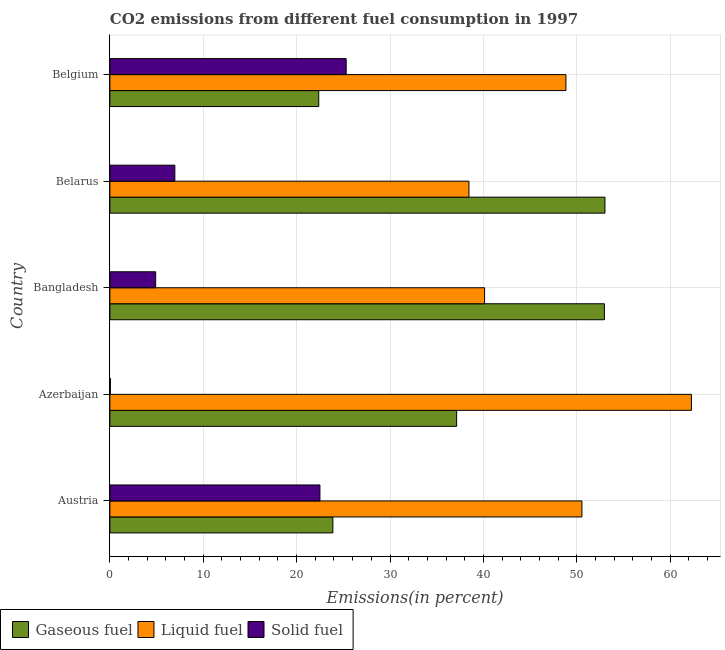How many different coloured bars are there?
Keep it short and to the point. 3. How many groups of bars are there?
Provide a succinct answer. 5. What is the label of the 2nd group of bars from the top?
Your response must be concise. Belarus. What is the percentage of liquid fuel emission in Belgium?
Your answer should be compact. 48.84. Across all countries, what is the maximum percentage of gaseous fuel emission?
Ensure brevity in your answer.  53.02. Across all countries, what is the minimum percentage of gaseous fuel emission?
Provide a succinct answer. 22.37. In which country was the percentage of gaseous fuel emission maximum?
Keep it short and to the point. Belarus. In which country was the percentage of liquid fuel emission minimum?
Offer a very short reply. Belarus. What is the total percentage of liquid fuel emission in the graph?
Provide a succinct answer. 240.27. What is the difference between the percentage of gaseous fuel emission in Austria and that in Azerbaijan?
Offer a terse response. -13.26. What is the difference between the percentage of gaseous fuel emission in Azerbaijan and the percentage of liquid fuel emission in Belgium?
Keep it short and to the point. -11.7. What is the average percentage of solid fuel emission per country?
Give a very brief answer. 11.94. What is the difference between the percentage of gaseous fuel emission and percentage of solid fuel emission in Azerbaijan?
Provide a short and direct response. 37.09. What is the ratio of the percentage of liquid fuel emission in Azerbaijan to that in Belgium?
Keep it short and to the point. 1.27. Is the difference between the percentage of liquid fuel emission in Austria and Bangladesh greater than the difference between the percentage of gaseous fuel emission in Austria and Bangladesh?
Make the answer very short. Yes. What is the difference between the highest and the second highest percentage of gaseous fuel emission?
Offer a terse response. 0.06. What is the difference between the highest and the lowest percentage of gaseous fuel emission?
Offer a terse response. 30.65. In how many countries, is the percentage of solid fuel emission greater than the average percentage of solid fuel emission taken over all countries?
Keep it short and to the point. 2. Is the sum of the percentage of liquid fuel emission in Azerbaijan and Bangladesh greater than the maximum percentage of gaseous fuel emission across all countries?
Give a very brief answer. Yes. What does the 2nd bar from the top in Belarus represents?
Your answer should be compact. Liquid fuel. What does the 3rd bar from the bottom in Azerbaijan represents?
Offer a terse response. Solid fuel. How many countries are there in the graph?
Make the answer very short. 5. What is the difference between two consecutive major ticks on the X-axis?
Ensure brevity in your answer.  10. Does the graph contain grids?
Make the answer very short. Yes. Where does the legend appear in the graph?
Provide a succinct answer. Bottom left. What is the title of the graph?
Ensure brevity in your answer.  CO2 emissions from different fuel consumption in 1997. What is the label or title of the X-axis?
Your answer should be compact. Emissions(in percent). What is the Emissions(in percent) of Gaseous fuel in Austria?
Offer a terse response. 23.88. What is the Emissions(in percent) in Liquid fuel in Austria?
Your response must be concise. 50.56. What is the Emissions(in percent) in Solid fuel in Austria?
Your answer should be very brief. 22.5. What is the Emissions(in percent) of Gaseous fuel in Azerbaijan?
Keep it short and to the point. 37.14. What is the Emissions(in percent) in Liquid fuel in Azerbaijan?
Your answer should be very brief. 62.28. What is the Emissions(in percent) of Solid fuel in Azerbaijan?
Provide a succinct answer. 0.05. What is the Emissions(in percent) in Gaseous fuel in Bangladesh?
Make the answer very short. 52.96. What is the Emissions(in percent) in Liquid fuel in Bangladesh?
Offer a very short reply. 40.13. What is the Emissions(in percent) in Solid fuel in Bangladesh?
Ensure brevity in your answer.  4.9. What is the Emissions(in percent) in Gaseous fuel in Belarus?
Give a very brief answer. 53.02. What is the Emissions(in percent) in Liquid fuel in Belarus?
Offer a terse response. 38.46. What is the Emissions(in percent) of Solid fuel in Belarus?
Your answer should be very brief. 6.96. What is the Emissions(in percent) in Gaseous fuel in Belgium?
Your answer should be compact. 22.37. What is the Emissions(in percent) of Liquid fuel in Belgium?
Ensure brevity in your answer.  48.84. What is the Emissions(in percent) of Solid fuel in Belgium?
Offer a terse response. 25.31. Across all countries, what is the maximum Emissions(in percent) of Gaseous fuel?
Provide a succinct answer. 53.02. Across all countries, what is the maximum Emissions(in percent) of Liquid fuel?
Your answer should be very brief. 62.28. Across all countries, what is the maximum Emissions(in percent) of Solid fuel?
Provide a succinct answer. 25.31. Across all countries, what is the minimum Emissions(in percent) of Gaseous fuel?
Keep it short and to the point. 22.37. Across all countries, what is the minimum Emissions(in percent) in Liquid fuel?
Make the answer very short. 38.46. Across all countries, what is the minimum Emissions(in percent) in Solid fuel?
Provide a succinct answer. 0.05. What is the total Emissions(in percent) of Gaseous fuel in the graph?
Your answer should be compact. 189.38. What is the total Emissions(in percent) of Liquid fuel in the graph?
Provide a succinct answer. 240.27. What is the total Emissions(in percent) of Solid fuel in the graph?
Offer a very short reply. 59.71. What is the difference between the Emissions(in percent) of Gaseous fuel in Austria and that in Azerbaijan?
Your answer should be compact. -13.26. What is the difference between the Emissions(in percent) in Liquid fuel in Austria and that in Azerbaijan?
Provide a short and direct response. -11.73. What is the difference between the Emissions(in percent) of Solid fuel in Austria and that in Azerbaijan?
Your answer should be compact. 22.45. What is the difference between the Emissions(in percent) of Gaseous fuel in Austria and that in Bangladesh?
Offer a very short reply. -29.08. What is the difference between the Emissions(in percent) of Liquid fuel in Austria and that in Bangladesh?
Keep it short and to the point. 10.42. What is the difference between the Emissions(in percent) of Solid fuel in Austria and that in Bangladesh?
Provide a short and direct response. 17.6. What is the difference between the Emissions(in percent) of Gaseous fuel in Austria and that in Belarus?
Offer a very short reply. -29.14. What is the difference between the Emissions(in percent) of Liquid fuel in Austria and that in Belarus?
Your answer should be compact. 12.1. What is the difference between the Emissions(in percent) of Solid fuel in Austria and that in Belarus?
Ensure brevity in your answer.  15.54. What is the difference between the Emissions(in percent) in Gaseous fuel in Austria and that in Belgium?
Ensure brevity in your answer.  1.51. What is the difference between the Emissions(in percent) in Liquid fuel in Austria and that in Belgium?
Offer a terse response. 1.71. What is the difference between the Emissions(in percent) in Solid fuel in Austria and that in Belgium?
Your answer should be very brief. -2.81. What is the difference between the Emissions(in percent) of Gaseous fuel in Azerbaijan and that in Bangladesh?
Provide a short and direct response. -15.82. What is the difference between the Emissions(in percent) of Liquid fuel in Azerbaijan and that in Bangladesh?
Your answer should be very brief. 22.15. What is the difference between the Emissions(in percent) in Solid fuel in Azerbaijan and that in Bangladesh?
Keep it short and to the point. -4.85. What is the difference between the Emissions(in percent) of Gaseous fuel in Azerbaijan and that in Belarus?
Provide a succinct answer. -15.88. What is the difference between the Emissions(in percent) in Liquid fuel in Azerbaijan and that in Belarus?
Make the answer very short. 23.83. What is the difference between the Emissions(in percent) of Solid fuel in Azerbaijan and that in Belarus?
Offer a terse response. -6.91. What is the difference between the Emissions(in percent) in Gaseous fuel in Azerbaijan and that in Belgium?
Keep it short and to the point. 14.77. What is the difference between the Emissions(in percent) of Liquid fuel in Azerbaijan and that in Belgium?
Provide a succinct answer. 13.44. What is the difference between the Emissions(in percent) of Solid fuel in Azerbaijan and that in Belgium?
Your answer should be very brief. -25.26. What is the difference between the Emissions(in percent) of Gaseous fuel in Bangladesh and that in Belarus?
Offer a terse response. -0.06. What is the difference between the Emissions(in percent) of Liquid fuel in Bangladesh and that in Belarus?
Your response must be concise. 1.67. What is the difference between the Emissions(in percent) of Solid fuel in Bangladesh and that in Belarus?
Offer a very short reply. -2.05. What is the difference between the Emissions(in percent) in Gaseous fuel in Bangladesh and that in Belgium?
Ensure brevity in your answer.  30.59. What is the difference between the Emissions(in percent) of Liquid fuel in Bangladesh and that in Belgium?
Provide a short and direct response. -8.71. What is the difference between the Emissions(in percent) in Solid fuel in Bangladesh and that in Belgium?
Keep it short and to the point. -20.41. What is the difference between the Emissions(in percent) of Gaseous fuel in Belarus and that in Belgium?
Provide a succinct answer. 30.65. What is the difference between the Emissions(in percent) of Liquid fuel in Belarus and that in Belgium?
Offer a very short reply. -10.39. What is the difference between the Emissions(in percent) in Solid fuel in Belarus and that in Belgium?
Give a very brief answer. -18.35. What is the difference between the Emissions(in percent) of Gaseous fuel in Austria and the Emissions(in percent) of Liquid fuel in Azerbaijan?
Ensure brevity in your answer.  -38.4. What is the difference between the Emissions(in percent) of Gaseous fuel in Austria and the Emissions(in percent) of Solid fuel in Azerbaijan?
Your response must be concise. 23.83. What is the difference between the Emissions(in percent) in Liquid fuel in Austria and the Emissions(in percent) in Solid fuel in Azerbaijan?
Provide a short and direct response. 50.51. What is the difference between the Emissions(in percent) of Gaseous fuel in Austria and the Emissions(in percent) of Liquid fuel in Bangladesh?
Your answer should be very brief. -16.25. What is the difference between the Emissions(in percent) in Gaseous fuel in Austria and the Emissions(in percent) in Solid fuel in Bangladesh?
Your answer should be compact. 18.98. What is the difference between the Emissions(in percent) in Liquid fuel in Austria and the Emissions(in percent) in Solid fuel in Bangladesh?
Make the answer very short. 45.65. What is the difference between the Emissions(in percent) in Gaseous fuel in Austria and the Emissions(in percent) in Liquid fuel in Belarus?
Provide a succinct answer. -14.57. What is the difference between the Emissions(in percent) of Gaseous fuel in Austria and the Emissions(in percent) of Solid fuel in Belarus?
Your answer should be very brief. 16.93. What is the difference between the Emissions(in percent) of Liquid fuel in Austria and the Emissions(in percent) of Solid fuel in Belarus?
Give a very brief answer. 43.6. What is the difference between the Emissions(in percent) in Gaseous fuel in Austria and the Emissions(in percent) in Liquid fuel in Belgium?
Your answer should be very brief. -24.96. What is the difference between the Emissions(in percent) in Gaseous fuel in Austria and the Emissions(in percent) in Solid fuel in Belgium?
Keep it short and to the point. -1.42. What is the difference between the Emissions(in percent) of Liquid fuel in Austria and the Emissions(in percent) of Solid fuel in Belgium?
Keep it short and to the point. 25.25. What is the difference between the Emissions(in percent) in Gaseous fuel in Azerbaijan and the Emissions(in percent) in Liquid fuel in Bangladesh?
Make the answer very short. -2.99. What is the difference between the Emissions(in percent) in Gaseous fuel in Azerbaijan and the Emissions(in percent) in Solid fuel in Bangladesh?
Offer a terse response. 32.24. What is the difference between the Emissions(in percent) of Liquid fuel in Azerbaijan and the Emissions(in percent) of Solid fuel in Bangladesh?
Offer a very short reply. 57.38. What is the difference between the Emissions(in percent) in Gaseous fuel in Azerbaijan and the Emissions(in percent) in Liquid fuel in Belarus?
Ensure brevity in your answer.  -1.32. What is the difference between the Emissions(in percent) of Gaseous fuel in Azerbaijan and the Emissions(in percent) of Solid fuel in Belarus?
Offer a very short reply. 30.18. What is the difference between the Emissions(in percent) in Liquid fuel in Azerbaijan and the Emissions(in percent) in Solid fuel in Belarus?
Make the answer very short. 55.33. What is the difference between the Emissions(in percent) in Gaseous fuel in Azerbaijan and the Emissions(in percent) in Liquid fuel in Belgium?
Your answer should be compact. -11.7. What is the difference between the Emissions(in percent) in Gaseous fuel in Azerbaijan and the Emissions(in percent) in Solid fuel in Belgium?
Provide a succinct answer. 11.83. What is the difference between the Emissions(in percent) of Liquid fuel in Azerbaijan and the Emissions(in percent) of Solid fuel in Belgium?
Your answer should be very brief. 36.98. What is the difference between the Emissions(in percent) in Gaseous fuel in Bangladesh and the Emissions(in percent) in Liquid fuel in Belarus?
Your response must be concise. 14.51. What is the difference between the Emissions(in percent) of Gaseous fuel in Bangladesh and the Emissions(in percent) of Solid fuel in Belarus?
Keep it short and to the point. 46.01. What is the difference between the Emissions(in percent) in Liquid fuel in Bangladesh and the Emissions(in percent) in Solid fuel in Belarus?
Ensure brevity in your answer.  33.18. What is the difference between the Emissions(in percent) of Gaseous fuel in Bangladesh and the Emissions(in percent) of Liquid fuel in Belgium?
Give a very brief answer. 4.12. What is the difference between the Emissions(in percent) of Gaseous fuel in Bangladesh and the Emissions(in percent) of Solid fuel in Belgium?
Make the answer very short. 27.66. What is the difference between the Emissions(in percent) of Liquid fuel in Bangladesh and the Emissions(in percent) of Solid fuel in Belgium?
Your response must be concise. 14.82. What is the difference between the Emissions(in percent) of Gaseous fuel in Belarus and the Emissions(in percent) of Liquid fuel in Belgium?
Offer a very short reply. 4.18. What is the difference between the Emissions(in percent) in Gaseous fuel in Belarus and the Emissions(in percent) in Solid fuel in Belgium?
Offer a very short reply. 27.72. What is the difference between the Emissions(in percent) in Liquid fuel in Belarus and the Emissions(in percent) in Solid fuel in Belgium?
Your response must be concise. 13.15. What is the average Emissions(in percent) of Gaseous fuel per country?
Make the answer very short. 37.88. What is the average Emissions(in percent) of Liquid fuel per country?
Ensure brevity in your answer.  48.05. What is the average Emissions(in percent) in Solid fuel per country?
Your response must be concise. 11.94. What is the difference between the Emissions(in percent) of Gaseous fuel and Emissions(in percent) of Liquid fuel in Austria?
Keep it short and to the point. -26.67. What is the difference between the Emissions(in percent) of Gaseous fuel and Emissions(in percent) of Solid fuel in Austria?
Offer a very short reply. 1.39. What is the difference between the Emissions(in percent) of Liquid fuel and Emissions(in percent) of Solid fuel in Austria?
Keep it short and to the point. 28.06. What is the difference between the Emissions(in percent) of Gaseous fuel and Emissions(in percent) of Liquid fuel in Azerbaijan?
Give a very brief answer. -25.14. What is the difference between the Emissions(in percent) in Gaseous fuel and Emissions(in percent) in Solid fuel in Azerbaijan?
Your response must be concise. 37.09. What is the difference between the Emissions(in percent) in Liquid fuel and Emissions(in percent) in Solid fuel in Azerbaijan?
Provide a succinct answer. 62.23. What is the difference between the Emissions(in percent) in Gaseous fuel and Emissions(in percent) in Liquid fuel in Bangladesh?
Offer a terse response. 12.83. What is the difference between the Emissions(in percent) in Gaseous fuel and Emissions(in percent) in Solid fuel in Bangladesh?
Your answer should be very brief. 48.06. What is the difference between the Emissions(in percent) in Liquid fuel and Emissions(in percent) in Solid fuel in Bangladesh?
Your response must be concise. 35.23. What is the difference between the Emissions(in percent) in Gaseous fuel and Emissions(in percent) in Liquid fuel in Belarus?
Ensure brevity in your answer.  14.56. What is the difference between the Emissions(in percent) in Gaseous fuel and Emissions(in percent) in Solid fuel in Belarus?
Your answer should be very brief. 46.07. What is the difference between the Emissions(in percent) in Liquid fuel and Emissions(in percent) in Solid fuel in Belarus?
Your answer should be compact. 31.5. What is the difference between the Emissions(in percent) of Gaseous fuel and Emissions(in percent) of Liquid fuel in Belgium?
Ensure brevity in your answer.  -26.47. What is the difference between the Emissions(in percent) of Gaseous fuel and Emissions(in percent) of Solid fuel in Belgium?
Provide a succinct answer. -2.94. What is the difference between the Emissions(in percent) in Liquid fuel and Emissions(in percent) in Solid fuel in Belgium?
Provide a succinct answer. 23.54. What is the ratio of the Emissions(in percent) of Gaseous fuel in Austria to that in Azerbaijan?
Offer a very short reply. 0.64. What is the ratio of the Emissions(in percent) in Liquid fuel in Austria to that in Azerbaijan?
Keep it short and to the point. 0.81. What is the ratio of the Emissions(in percent) in Solid fuel in Austria to that in Azerbaijan?
Keep it short and to the point. 457.2. What is the ratio of the Emissions(in percent) in Gaseous fuel in Austria to that in Bangladesh?
Give a very brief answer. 0.45. What is the ratio of the Emissions(in percent) in Liquid fuel in Austria to that in Bangladesh?
Provide a succinct answer. 1.26. What is the ratio of the Emissions(in percent) of Solid fuel in Austria to that in Bangladesh?
Provide a short and direct response. 4.59. What is the ratio of the Emissions(in percent) of Gaseous fuel in Austria to that in Belarus?
Provide a short and direct response. 0.45. What is the ratio of the Emissions(in percent) of Liquid fuel in Austria to that in Belarus?
Ensure brevity in your answer.  1.31. What is the ratio of the Emissions(in percent) in Solid fuel in Austria to that in Belarus?
Make the answer very short. 3.23. What is the ratio of the Emissions(in percent) of Gaseous fuel in Austria to that in Belgium?
Provide a succinct answer. 1.07. What is the ratio of the Emissions(in percent) of Liquid fuel in Austria to that in Belgium?
Ensure brevity in your answer.  1.04. What is the ratio of the Emissions(in percent) in Solid fuel in Austria to that in Belgium?
Offer a terse response. 0.89. What is the ratio of the Emissions(in percent) in Gaseous fuel in Azerbaijan to that in Bangladesh?
Make the answer very short. 0.7. What is the ratio of the Emissions(in percent) in Liquid fuel in Azerbaijan to that in Bangladesh?
Provide a short and direct response. 1.55. What is the ratio of the Emissions(in percent) in Gaseous fuel in Azerbaijan to that in Belarus?
Offer a terse response. 0.7. What is the ratio of the Emissions(in percent) of Liquid fuel in Azerbaijan to that in Belarus?
Provide a succinct answer. 1.62. What is the ratio of the Emissions(in percent) in Solid fuel in Azerbaijan to that in Belarus?
Provide a short and direct response. 0.01. What is the ratio of the Emissions(in percent) of Gaseous fuel in Azerbaijan to that in Belgium?
Offer a terse response. 1.66. What is the ratio of the Emissions(in percent) of Liquid fuel in Azerbaijan to that in Belgium?
Give a very brief answer. 1.28. What is the ratio of the Emissions(in percent) of Solid fuel in Azerbaijan to that in Belgium?
Keep it short and to the point. 0. What is the ratio of the Emissions(in percent) in Gaseous fuel in Bangladesh to that in Belarus?
Offer a terse response. 1. What is the ratio of the Emissions(in percent) in Liquid fuel in Bangladesh to that in Belarus?
Provide a short and direct response. 1.04. What is the ratio of the Emissions(in percent) of Solid fuel in Bangladesh to that in Belarus?
Provide a short and direct response. 0.7. What is the ratio of the Emissions(in percent) of Gaseous fuel in Bangladesh to that in Belgium?
Your response must be concise. 2.37. What is the ratio of the Emissions(in percent) of Liquid fuel in Bangladesh to that in Belgium?
Your answer should be very brief. 0.82. What is the ratio of the Emissions(in percent) of Solid fuel in Bangladesh to that in Belgium?
Keep it short and to the point. 0.19. What is the ratio of the Emissions(in percent) in Gaseous fuel in Belarus to that in Belgium?
Make the answer very short. 2.37. What is the ratio of the Emissions(in percent) in Liquid fuel in Belarus to that in Belgium?
Provide a succinct answer. 0.79. What is the ratio of the Emissions(in percent) in Solid fuel in Belarus to that in Belgium?
Provide a short and direct response. 0.27. What is the difference between the highest and the second highest Emissions(in percent) of Gaseous fuel?
Provide a short and direct response. 0.06. What is the difference between the highest and the second highest Emissions(in percent) of Liquid fuel?
Keep it short and to the point. 11.73. What is the difference between the highest and the second highest Emissions(in percent) of Solid fuel?
Ensure brevity in your answer.  2.81. What is the difference between the highest and the lowest Emissions(in percent) in Gaseous fuel?
Provide a succinct answer. 30.65. What is the difference between the highest and the lowest Emissions(in percent) of Liquid fuel?
Offer a terse response. 23.83. What is the difference between the highest and the lowest Emissions(in percent) of Solid fuel?
Provide a short and direct response. 25.26. 